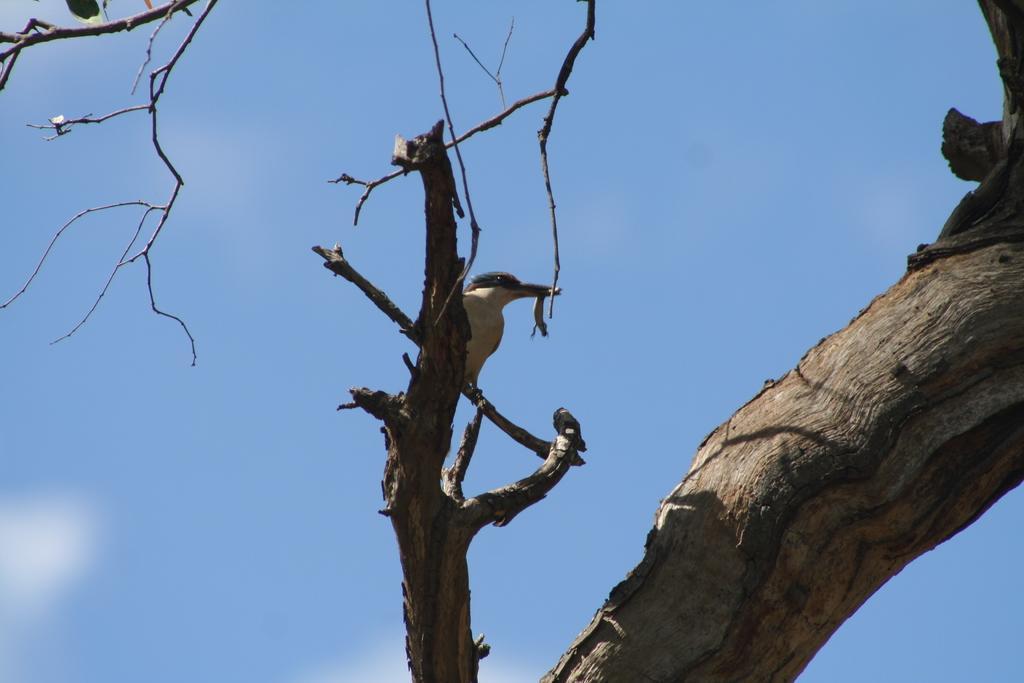In one or two sentences, can you explain what this image depicts? In the center of the image we can see one tree. On the tree, we can see one bird. In the background we can see the sky and clouds. 